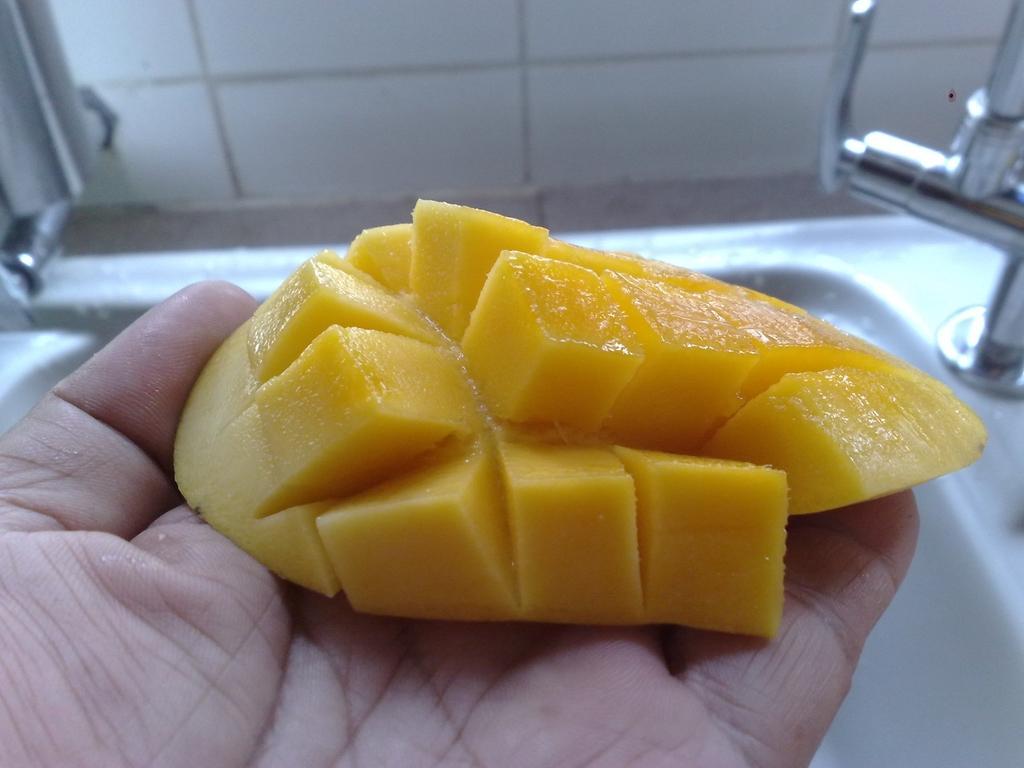Please provide a concise description of this image. In this picture we can observe a piece of mango which is in yellow color in the human hand. In the background we can observe a white color sink, tap and a wall. 